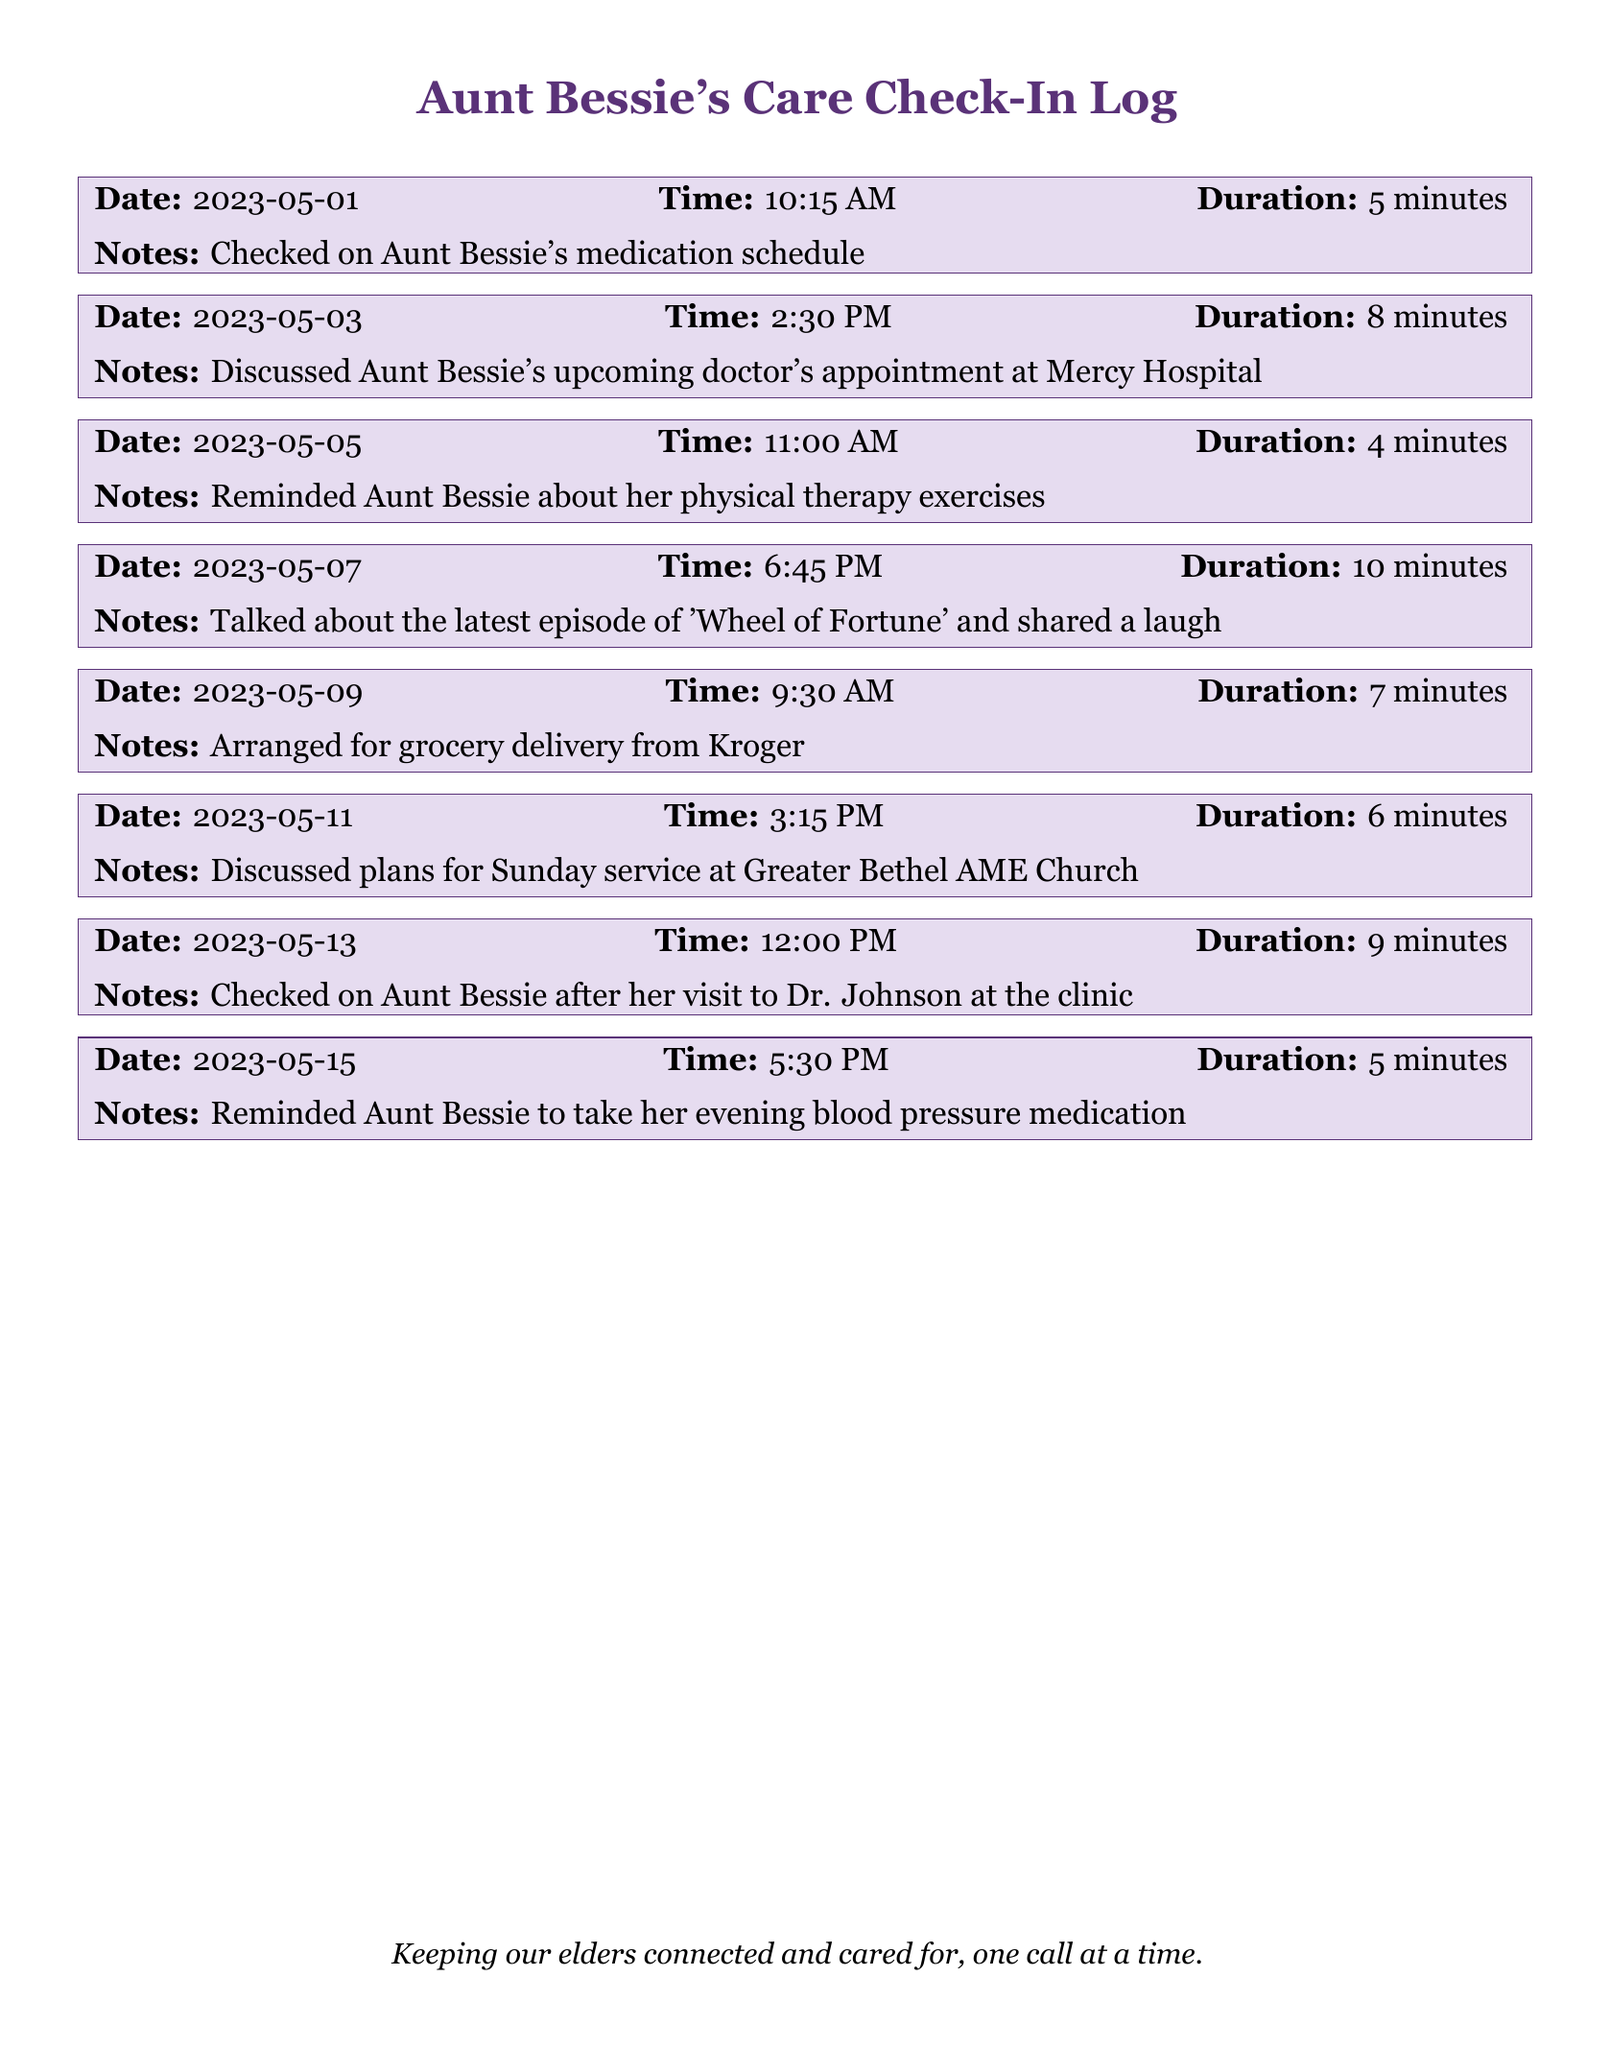What date was the first call made? The first call recorded is on May 1, 2023.
Answer: May 1, 2023 How long was the call on May 3, 2023? The call on that date lasted for 8 minutes.
Answer: 8 minutes What medication topic was discussed on May 15, 2023? The discussion was about Aunt Bessie's evening blood pressure medication.
Answer: Evening blood pressure medication How many minutes did the longest call last? The longest call was on May 7, lasting 10 minutes.
Answer: 10 minutes What was discussed during the call on May 13, 2023? The call was about checking on Aunt Bessie after her doctor visit.
Answer: Checked on Aunt Bessie after her visit to Dr. Johnson at the clinic What is the total number of calls logged in this document? There are a total of 8 calls listed in the document.
Answer: 8 What was the purpose of the call on May 5, 2023? The purpose was to remind Aunt Bessie about her physical therapy exercises.
Answer: Reminded Aunt Bessie about her physical therapy exercises Which day's call included a discussion about grocery delivery? The call on May 9, 2023, discussed grocery delivery from Kroger.
Answer: May 9, 2023 